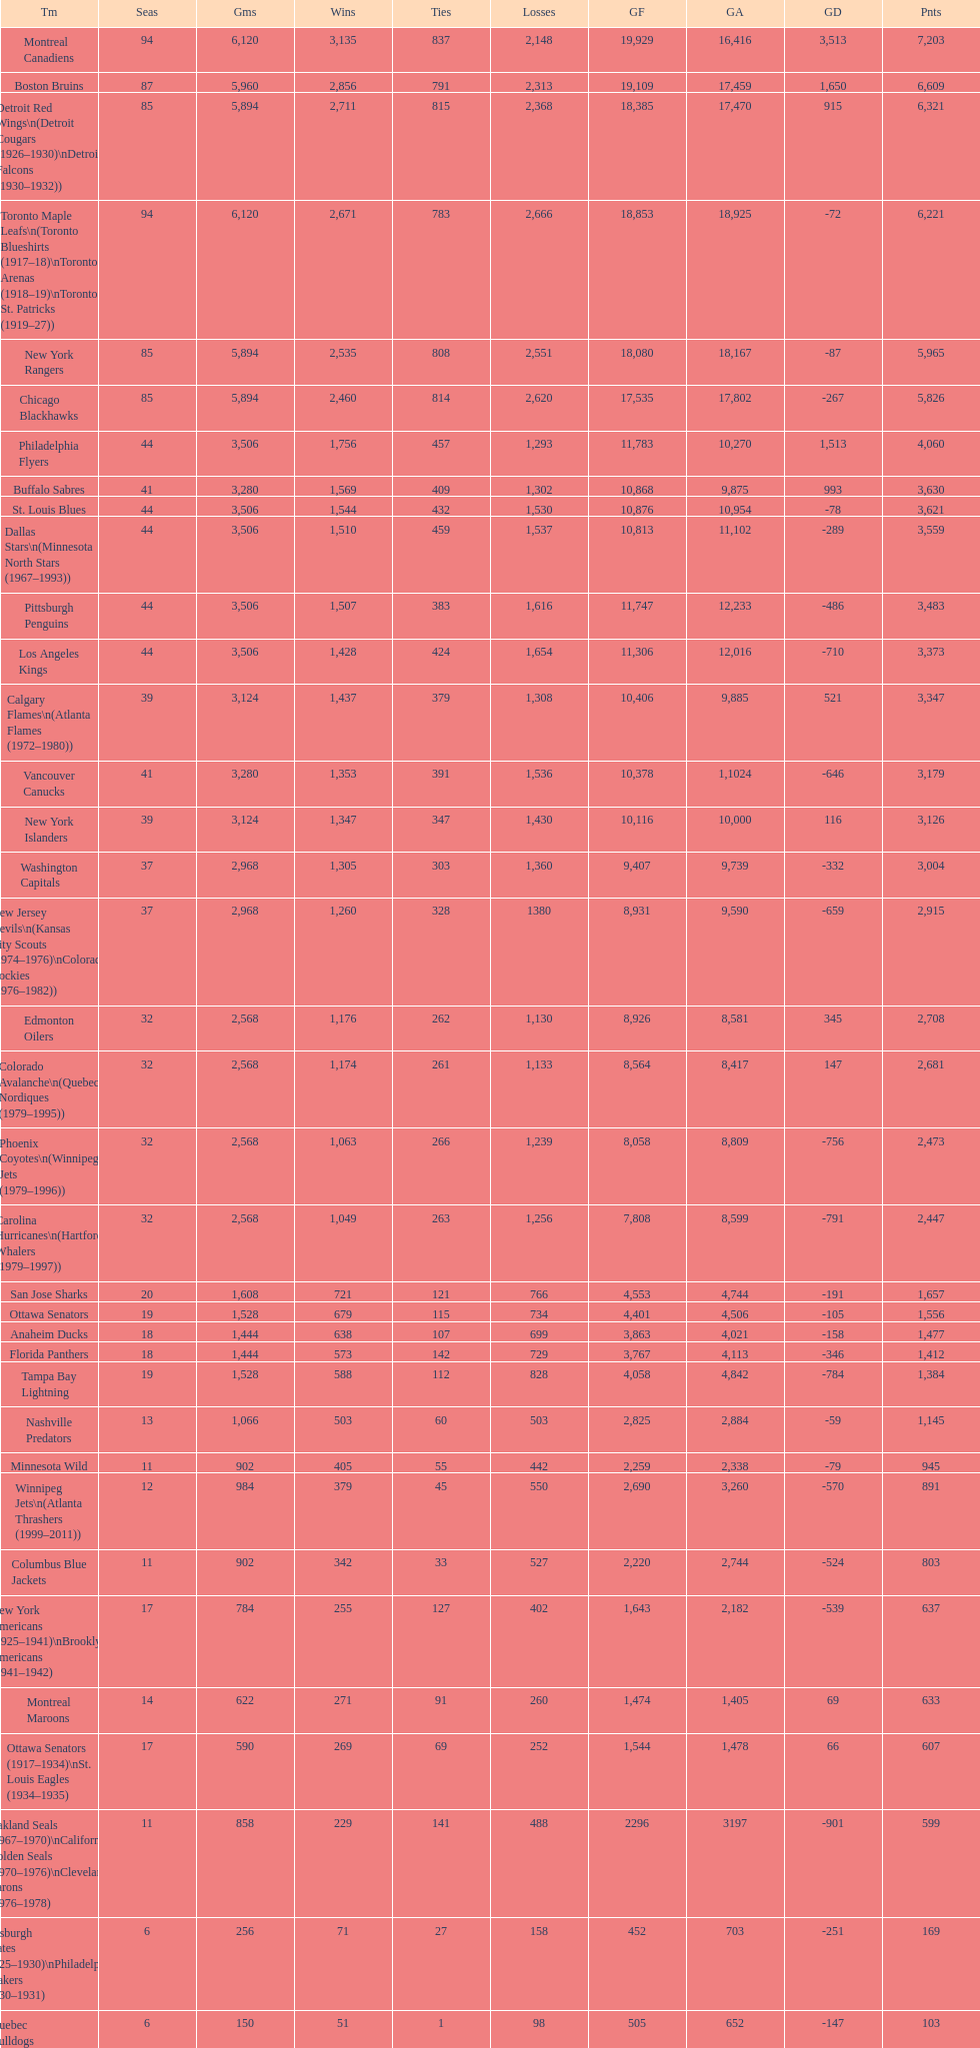Which team was last in terms of points up until this point? Montreal Wanderers. Could you help me parse every detail presented in this table? {'header': ['Tm', 'Seas', 'Gms', 'Wins', 'Ties', 'Losses', 'GF', 'GA', 'GD', 'Pnts'], 'rows': [['Montreal Canadiens', '94', '6,120', '3,135', '837', '2,148', '19,929', '16,416', '3,513', '7,203'], ['Boston Bruins', '87', '5,960', '2,856', '791', '2,313', '19,109', '17,459', '1,650', '6,609'], ['Detroit Red Wings\\n(Detroit Cougars (1926–1930)\\nDetroit Falcons (1930–1932))', '85', '5,894', '2,711', '815', '2,368', '18,385', '17,470', '915', '6,321'], ['Toronto Maple Leafs\\n(Toronto Blueshirts (1917–18)\\nToronto Arenas (1918–19)\\nToronto St. Patricks (1919–27))', '94', '6,120', '2,671', '783', '2,666', '18,853', '18,925', '-72', '6,221'], ['New York Rangers', '85', '5,894', '2,535', '808', '2,551', '18,080', '18,167', '-87', '5,965'], ['Chicago Blackhawks', '85', '5,894', '2,460', '814', '2,620', '17,535', '17,802', '-267', '5,826'], ['Philadelphia Flyers', '44', '3,506', '1,756', '457', '1,293', '11,783', '10,270', '1,513', '4,060'], ['Buffalo Sabres', '41', '3,280', '1,569', '409', '1,302', '10,868', '9,875', '993', '3,630'], ['St. Louis Blues', '44', '3,506', '1,544', '432', '1,530', '10,876', '10,954', '-78', '3,621'], ['Dallas Stars\\n(Minnesota North Stars (1967–1993))', '44', '3,506', '1,510', '459', '1,537', '10,813', '11,102', '-289', '3,559'], ['Pittsburgh Penguins', '44', '3,506', '1,507', '383', '1,616', '11,747', '12,233', '-486', '3,483'], ['Los Angeles Kings', '44', '3,506', '1,428', '424', '1,654', '11,306', '12,016', '-710', '3,373'], ['Calgary Flames\\n(Atlanta Flames (1972–1980))', '39', '3,124', '1,437', '379', '1,308', '10,406', '9,885', '521', '3,347'], ['Vancouver Canucks', '41', '3,280', '1,353', '391', '1,536', '10,378', '1,1024', '-646', '3,179'], ['New York Islanders', '39', '3,124', '1,347', '347', '1,430', '10,116', '10,000', '116', '3,126'], ['Washington Capitals', '37', '2,968', '1,305', '303', '1,360', '9,407', '9,739', '-332', '3,004'], ['New Jersey Devils\\n(Kansas City Scouts (1974–1976)\\nColorado Rockies (1976–1982))', '37', '2,968', '1,260', '328', '1380', '8,931', '9,590', '-659', '2,915'], ['Edmonton Oilers', '32', '2,568', '1,176', '262', '1,130', '8,926', '8,581', '345', '2,708'], ['Colorado Avalanche\\n(Quebec Nordiques (1979–1995))', '32', '2,568', '1,174', '261', '1,133', '8,564', '8,417', '147', '2,681'], ['Phoenix Coyotes\\n(Winnipeg Jets (1979–1996))', '32', '2,568', '1,063', '266', '1,239', '8,058', '8,809', '-756', '2,473'], ['Carolina Hurricanes\\n(Hartford Whalers (1979–1997))', '32', '2,568', '1,049', '263', '1,256', '7,808', '8,599', '-791', '2,447'], ['San Jose Sharks', '20', '1,608', '721', '121', '766', '4,553', '4,744', '-191', '1,657'], ['Ottawa Senators', '19', '1,528', '679', '115', '734', '4,401', '4,506', '-105', '1,556'], ['Anaheim Ducks', '18', '1,444', '638', '107', '699', '3,863', '4,021', '-158', '1,477'], ['Florida Panthers', '18', '1,444', '573', '142', '729', '3,767', '4,113', '-346', '1,412'], ['Tampa Bay Lightning', '19', '1,528', '588', '112', '828', '4,058', '4,842', '-784', '1,384'], ['Nashville Predators', '13', '1,066', '503', '60', '503', '2,825', '2,884', '-59', '1,145'], ['Minnesota Wild', '11', '902', '405', '55', '442', '2,259', '2,338', '-79', '945'], ['Winnipeg Jets\\n(Atlanta Thrashers (1999–2011))', '12', '984', '379', '45', '550', '2,690', '3,260', '-570', '891'], ['Columbus Blue Jackets', '11', '902', '342', '33', '527', '2,220', '2,744', '-524', '803'], ['New York Americans (1925–1941)\\nBrooklyn Americans (1941–1942)', '17', '784', '255', '127', '402', '1,643', '2,182', '-539', '637'], ['Montreal Maroons', '14', '622', '271', '91', '260', '1,474', '1,405', '69', '633'], ['Ottawa Senators (1917–1934)\\nSt. Louis Eagles (1934–1935)', '17', '590', '269', '69', '252', '1,544', '1,478', '66', '607'], ['Oakland Seals (1967–1970)\\nCalifornia Golden Seals (1970–1976)\\nCleveland Barons (1976–1978)', '11', '858', '229', '141', '488', '2296', '3197', '-901', '599'], ['Pittsburgh Pirates (1925–1930)\\nPhiladelphia Quakers (1930–1931)', '6', '256', '71', '27', '158', '452', '703', '-251', '169'], ['Quebec Bulldogs (1919–1920)\\nHamilton Tigers (1920–1925)', '6', '150', '51', '1', '98', '505', '652', '-147', '103'], ['Montreal Wanderers', '1', '6', '1', '0', '5', '17', '35', '-18', '2']]} 